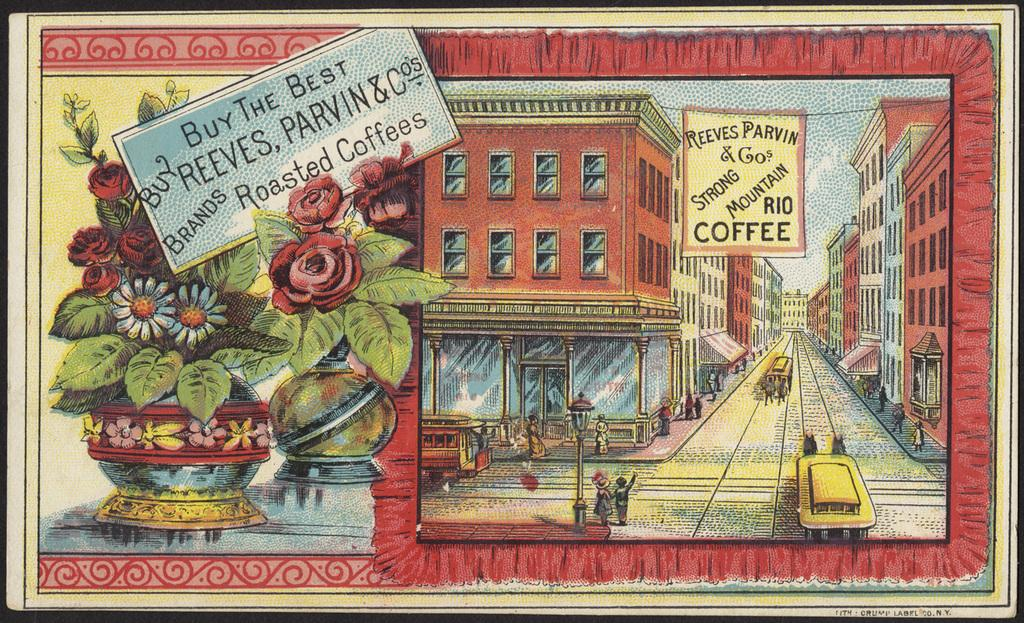<image>
Provide a brief description of the given image. An old advertisement for Reeves Parvin & Co's roasted coffee that has an old new york buildings setting in cartoon style artwork 